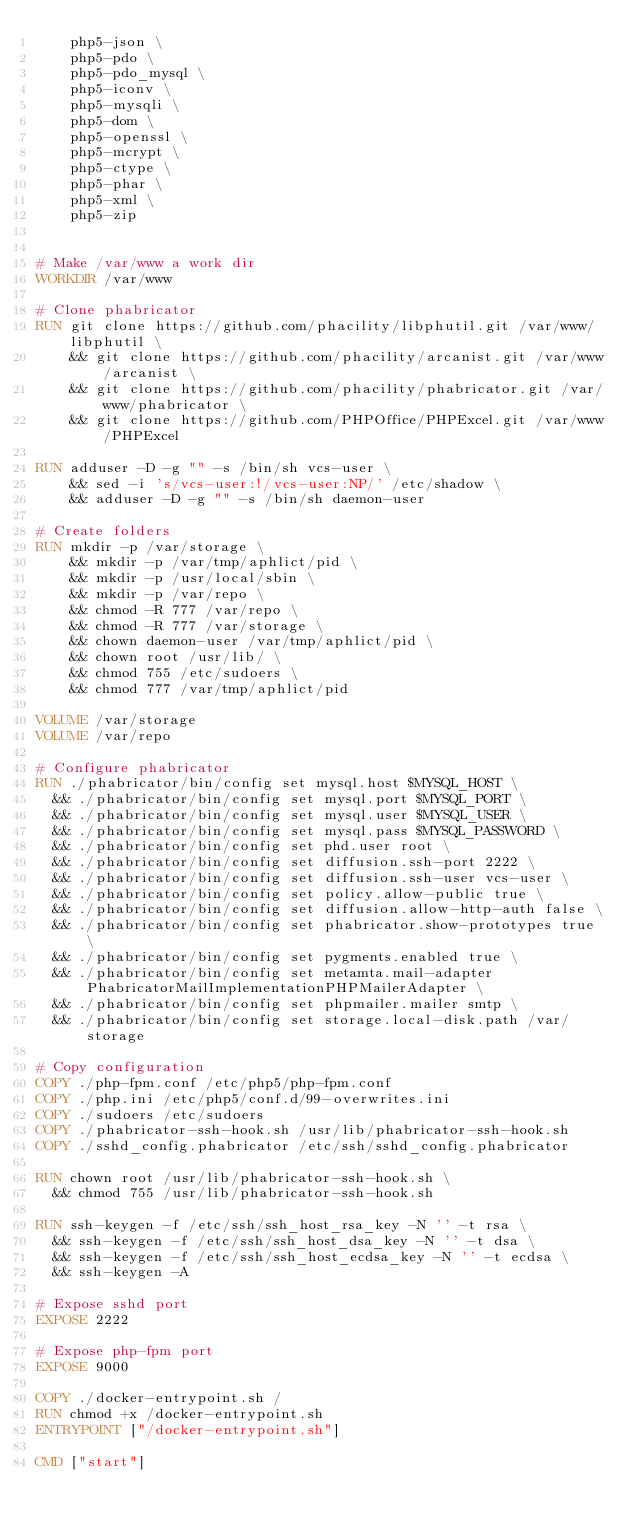<code> <loc_0><loc_0><loc_500><loc_500><_Dockerfile_>    php5-json \
    php5-pdo \
    php5-pdo_mysql \
    php5-iconv \
    php5-mysqli \
    php5-dom \
    php5-openssl \
    php5-mcrypt \
    php5-ctype \
    php5-phar \
    php5-xml \
    php5-zip


# Make /var/www a work dir
WORKDIR /var/www

# Clone phabricator
RUN git clone https://github.com/phacility/libphutil.git /var/www/libphutil \
    && git clone https://github.com/phacility/arcanist.git /var/www/arcanist \
    && git clone https://github.com/phacility/phabricator.git /var/www/phabricator \
    && git clone https://github.com/PHPOffice/PHPExcel.git /var/www/PHPExcel

RUN adduser -D -g "" -s /bin/sh vcs-user \
    && sed -i 's/vcs-user:!/vcs-user:NP/' /etc/shadow \
    && adduser -D -g "" -s /bin/sh daemon-user

# Create folders
RUN mkdir -p /var/storage \
    && mkdir -p /var/tmp/aphlict/pid \
    && mkdir -p /usr/local/sbin \
    && mkdir -p /var/repo \
    && chmod -R 777 /var/repo \
    && chmod -R 777 /var/storage \
    && chown daemon-user /var/tmp/aphlict/pid \
    && chown root /usr/lib/ \
    && chmod 755 /etc/sudoers \
    && chmod 777 /var/tmp/aphlict/pid

VOLUME /var/storage
VOLUME /var/repo

# Configure phabricator
RUN ./phabricator/bin/config set mysql.host $MYSQL_HOST \
  && ./phabricator/bin/config set mysql.port $MYSQL_PORT \
  && ./phabricator/bin/config set mysql.user $MYSQL_USER \
  && ./phabricator/bin/config set mysql.pass $MYSQL_PASSWORD \
  && ./phabricator/bin/config set phd.user root \
	&& ./phabricator/bin/config set diffusion.ssh-port 2222 \
  && ./phabricator/bin/config set diffusion.ssh-user vcs-user \
	&& ./phabricator/bin/config set policy.allow-public true \
	&& ./phabricator/bin/config set diffusion.allow-http-auth false \
	&& ./phabricator/bin/config set phabricator.show-prototypes true \
  && ./phabricator/bin/config set pygments.enabled true \
  && ./phabricator/bin/config set metamta.mail-adapter PhabricatorMailImplementationPHPMailerAdapter \
  && ./phabricator/bin/config set phpmailer.mailer smtp \
	&& ./phabricator/bin/config set storage.local-disk.path /var/storage

# Copy configuration
COPY ./php-fpm.conf /etc/php5/php-fpm.conf
COPY ./php.ini /etc/php5/conf.d/99-overwrites.ini
COPY ./sudoers /etc/sudoers
COPY ./phabricator-ssh-hook.sh /usr/lib/phabricator-ssh-hook.sh
COPY ./sshd_config.phabricator /etc/ssh/sshd_config.phabricator

RUN chown root /usr/lib/phabricator-ssh-hook.sh \
  && chmod 755 /usr/lib/phabricator-ssh-hook.sh

RUN ssh-keygen -f /etc/ssh/ssh_host_rsa_key -N '' -t rsa \
  && ssh-keygen -f /etc/ssh/ssh_host_dsa_key -N '' -t dsa \
	&& ssh-keygen -f /etc/ssh/ssh_host_ecdsa_key -N '' -t ecdsa \
	&& ssh-keygen -A

# Expose sshd port
EXPOSE 2222

# Expose php-fpm port
EXPOSE 9000

COPY ./docker-entrypoint.sh /
RUN chmod +x /docker-entrypoint.sh
ENTRYPOINT ["/docker-entrypoint.sh"]

CMD ["start"]
</code> 